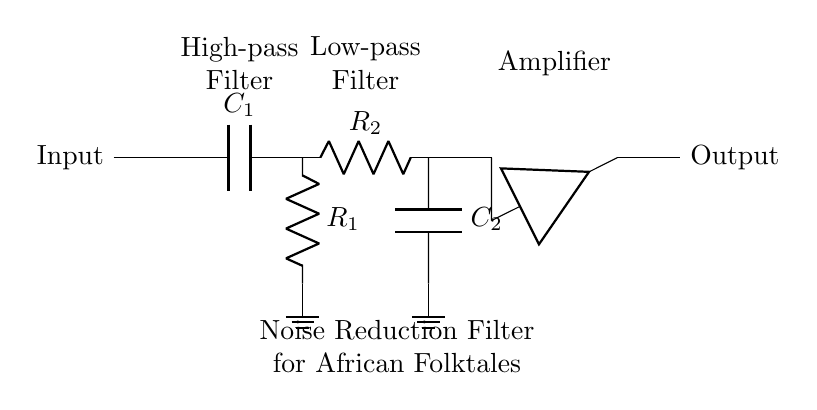What is the type of the first filter in the circuit? The first filter in the circuit is a high-pass filter as indicated by the capacitor labeled C1 followed by a resistor labeled R1. High-pass filters are designed to allow signals with a frequency higher than a certain cutoff frequency to pass through while attenuating lower frequencies.
Answer: High-pass filter What are the values of R1 and R2 in the circuit? The circuit diagram does not provide specific numerical values for R1 and R2; it only labels them as components without values. Therefore, one can only refer to them as generic resistors in the circuit.
Answer: Not specified What role does the amplifier play in this circuit? The amplifier in this circuit is used to increase the amplitude of the audio signal after it has passed through the high-pass and low-pass filters. Amplifiers are essential for boosting signals to improve audio quality in the context of digitized audio recordings.
Answer: Signal amplification What component follows the low-pass filter? Following the low-pass filter, which consists of R2 and C2, there is an amplifier in the circuit. The presence of the amplifier indicates that the filtered signal is to be boosted before output.
Answer: Amplifier How do the high-pass and low-pass filters work together? The high-pass filter allows higher frequency components of the audio signal to pass through while blocking lower frequencies. In contrast, the low-pass filter allows lower frequencies to pass while blocking higher ones. Together, they create a band-pass filter effect useful for enhancing specific audio qualities in the folktales.
Answer: Together, they create a band-pass filter effect 